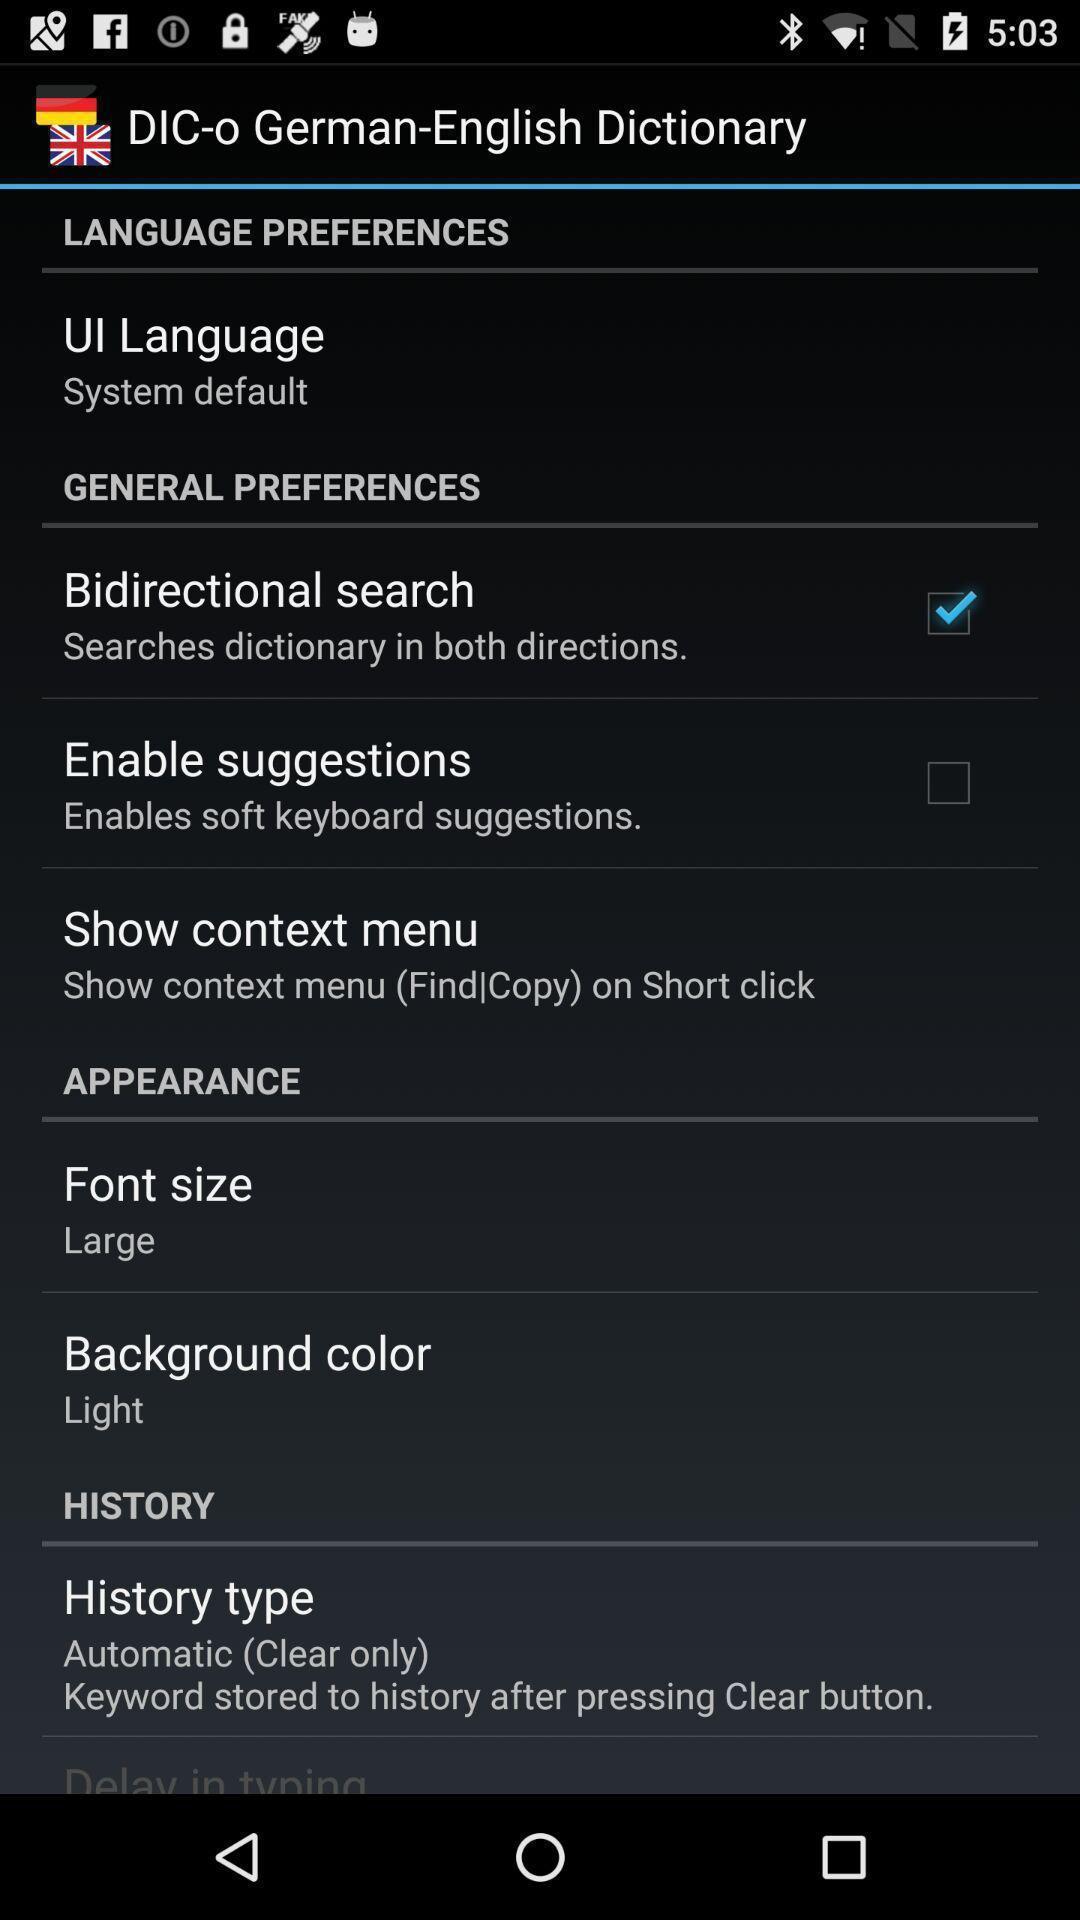Explain the elements present in this screenshot. Settings page of a dictionary app. 